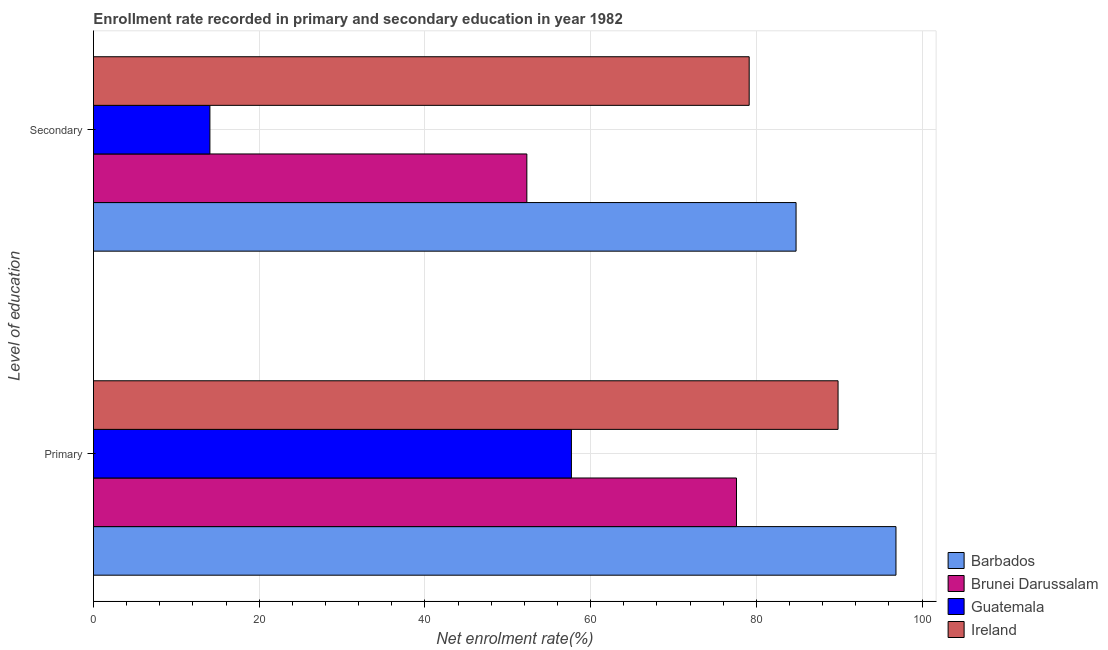How many groups of bars are there?
Provide a succinct answer. 2. Are the number of bars on each tick of the Y-axis equal?
Make the answer very short. Yes. How many bars are there on the 1st tick from the bottom?
Offer a terse response. 4. What is the label of the 1st group of bars from the top?
Keep it short and to the point. Secondary. What is the enrollment rate in secondary education in Guatemala?
Offer a terse response. 14.05. Across all countries, what is the maximum enrollment rate in secondary education?
Provide a succinct answer. 84.79. Across all countries, what is the minimum enrollment rate in secondary education?
Provide a short and direct response. 14.05. In which country was the enrollment rate in secondary education maximum?
Make the answer very short. Barbados. In which country was the enrollment rate in primary education minimum?
Your answer should be very brief. Guatemala. What is the total enrollment rate in primary education in the graph?
Your answer should be compact. 321.99. What is the difference between the enrollment rate in secondary education in Guatemala and that in Ireland?
Offer a very short reply. -65.08. What is the difference between the enrollment rate in primary education in Barbados and the enrollment rate in secondary education in Ireland?
Keep it short and to the point. 17.72. What is the average enrollment rate in primary education per country?
Your answer should be compact. 80.5. What is the difference between the enrollment rate in secondary education and enrollment rate in primary education in Guatemala?
Your answer should be very brief. -43.63. In how many countries, is the enrollment rate in primary education greater than 12 %?
Your response must be concise. 4. What is the ratio of the enrollment rate in secondary education in Brunei Darussalam to that in Guatemala?
Give a very brief answer. 3.72. Is the enrollment rate in secondary education in Ireland less than that in Guatemala?
Your response must be concise. No. In how many countries, is the enrollment rate in secondary education greater than the average enrollment rate in secondary education taken over all countries?
Offer a very short reply. 2. What does the 2nd bar from the top in Secondary represents?
Ensure brevity in your answer.  Guatemala. What does the 1st bar from the bottom in Secondary represents?
Offer a terse response. Barbados. Are all the bars in the graph horizontal?
Provide a succinct answer. Yes. What is the difference between two consecutive major ticks on the X-axis?
Provide a succinct answer. 20. Are the values on the major ticks of X-axis written in scientific E-notation?
Ensure brevity in your answer.  No. Does the graph contain any zero values?
Your answer should be very brief. No. How are the legend labels stacked?
Provide a short and direct response. Vertical. What is the title of the graph?
Provide a short and direct response. Enrollment rate recorded in primary and secondary education in year 1982. Does "Denmark" appear as one of the legend labels in the graph?
Your answer should be very brief. No. What is the label or title of the X-axis?
Your answer should be very brief. Net enrolment rate(%). What is the label or title of the Y-axis?
Ensure brevity in your answer.  Level of education. What is the Net enrolment rate(%) in Barbados in Primary?
Offer a very short reply. 96.85. What is the Net enrolment rate(%) in Brunei Darussalam in Primary?
Provide a short and direct response. 77.6. What is the Net enrolment rate(%) in Guatemala in Primary?
Your answer should be very brief. 57.68. What is the Net enrolment rate(%) of Ireland in Primary?
Give a very brief answer. 89.86. What is the Net enrolment rate(%) in Barbados in Secondary?
Give a very brief answer. 84.79. What is the Net enrolment rate(%) in Brunei Darussalam in Secondary?
Keep it short and to the point. 52.3. What is the Net enrolment rate(%) of Guatemala in Secondary?
Your response must be concise. 14.05. What is the Net enrolment rate(%) of Ireland in Secondary?
Give a very brief answer. 79.13. Across all Level of education, what is the maximum Net enrolment rate(%) in Barbados?
Give a very brief answer. 96.85. Across all Level of education, what is the maximum Net enrolment rate(%) in Brunei Darussalam?
Ensure brevity in your answer.  77.6. Across all Level of education, what is the maximum Net enrolment rate(%) in Guatemala?
Give a very brief answer. 57.68. Across all Level of education, what is the maximum Net enrolment rate(%) of Ireland?
Make the answer very short. 89.86. Across all Level of education, what is the minimum Net enrolment rate(%) of Barbados?
Provide a short and direct response. 84.79. Across all Level of education, what is the minimum Net enrolment rate(%) of Brunei Darussalam?
Make the answer very short. 52.3. Across all Level of education, what is the minimum Net enrolment rate(%) in Guatemala?
Offer a very short reply. 14.05. Across all Level of education, what is the minimum Net enrolment rate(%) of Ireland?
Your answer should be compact. 79.13. What is the total Net enrolment rate(%) of Barbados in the graph?
Your answer should be compact. 181.64. What is the total Net enrolment rate(%) in Brunei Darussalam in the graph?
Offer a terse response. 129.9. What is the total Net enrolment rate(%) of Guatemala in the graph?
Provide a succinct answer. 71.73. What is the total Net enrolment rate(%) in Ireland in the graph?
Keep it short and to the point. 168.99. What is the difference between the Net enrolment rate(%) of Barbados in Primary and that in Secondary?
Make the answer very short. 12.06. What is the difference between the Net enrolment rate(%) of Brunei Darussalam in Primary and that in Secondary?
Make the answer very short. 25.3. What is the difference between the Net enrolment rate(%) of Guatemala in Primary and that in Secondary?
Offer a terse response. 43.63. What is the difference between the Net enrolment rate(%) in Ireland in Primary and that in Secondary?
Provide a succinct answer. 10.73. What is the difference between the Net enrolment rate(%) of Barbados in Primary and the Net enrolment rate(%) of Brunei Darussalam in Secondary?
Offer a very short reply. 44.55. What is the difference between the Net enrolment rate(%) of Barbados in Primary and the Net enrolment rate(%) of Guatemala in Secondary?
Provide a succinct answer. 82.8. What is the difference between the Net enrolment rate(%) of Barbados in Primary and the Net enrolment rate(%) of Ireland in Secondary?
Your answer should be compact. 17.72. What is the difference between the Net enrolment rate(%) of Brunei Darussalam in Primary and the Net enrolment rate(%) of Guatemala in Secondary?
Provide a succinct answer. 63.55. What is the difference between the Net enrolment rate(%) of Brunei Darussalam in Primary and the Net enrolment rate(%) of Ireland in Secondary?
Your response must be concise. -1.53. What is the difference between the Net enrolment rate(%) in Guatemala in Primary and the Net enrolment rate(%) in Ireland in Secondary?
Make the answer very short. -21.45. What is the average Net enrolment rate(%) of Barbados per Level of education?
Offer a very short reply. 90.82. What is the average Net enrolment rate(%) in Brunei Darussalam per Level of education?
Ensure brevity in your answer.  64.95. What is the average Net enrolment rate(%) of Guatemala per Level of education?
Keep it short and to the point. 35.87. What is the average Net enrolment rate(%) of Ireland per Level of education?
Keep it short and to the point. 84.5. What is the difference between the Net enrolment rate(%) of Barbados and Net enrolment rate(%) of Brunei Darussalam in Primary?
Give a very brief answer. 19.25. What is the difference between the Net enrolment rate(%) of Barbados and Net enrolment rate(%) of Guatemala in Primary?
Provide a succinct answer. 39.17. What is the difference between the Net enrolment rate(%) of Barbados and Net enrolment rate(%) of Ireland in Primary?
Offer a terse response. 6.99. What is the difference between the Net enrolment rate(%) in Brunei Darussalam and Net enrolment rate(%) in Guatemala in Primary?
Keep it short and to the point. 19.92. What is the difference between the Net enrolment rate(%) in Brunei Darussalam and Net enrolment rate(%) in Ireland in Primary?
Give a very brief answer. -12.26. What is the difference between the Net enrolment rate(%) in Guatemala and Net enrolment rate(%) in Ireland in Primary?
Ensure brevity in your answer.  -32.18. What is the difference between the Net enrolment rate(%) in Barbados and Net enrolment rate(%) in Brunei Darussalam in Secondary?
Give a very brief answer. 32.49. What is the difference between the Net enrolment rate(%) in Barbados and Net enrolment rate(%) in Guatemala in Secondary?
Offer a terse response. 70.74. What is the difference between the Net enrolment rate(%) of Barbados and Net enrolment rate(%) of Ireland in Secondary?
Your answer should be very brief. 5.66. What is the difference between the Net enrolment rate(%) in Brunei Darussalam and Net enrolment rate(%) in Guatemala in Secondary?
Make the answer very short. 38.25. What is the difference between the Net enrolment rate(%) in Brunei Darussalam and Net enrolment rate(%) in Ireland in Secondary?
Provide a succinct answer. -26.83. What is the difference between the Net enrolment rate(%) in Guatemala and Net enrolment rate(%) in Ireland in Secondary?
Provide a short and direct response. -65.08. What is the ratio of the Net enrolment rate(%) in Barbados in Primary to that in Secondary?
Your answer should be very brief. 1.14. What is the ratio of the Net enrolment rate(%) of Brunei Darussalam in Primary to that in Secondary?
Ensure brevity in your answer.  1.48. What is the ratio of the Net enrolment rate(%) of Guatemala in Primary to that in Secondary?
Make the answer very short. 4.1. What is the ratio of the Net enrolment rate(%) of Ireland in Primary to that in Secondary?
Keep it short and to the point. 1.14. What is the difference between the highest and the second highest Net enrolment rate(%) in Barbados?
Your answer should be compact. 12.06. What is the difference between the highest and the second highest Net enrolment rate(%) in Brunei Darussalam?
Provide a short and direct response. 25.3. What is the difference between the highest and the second highest Net enrolment rate(%) in Guatemala?
Offer a terse response. 43.63. What is the difference between the highest and the second highest Net enrolment rate(%) of Ireland?
Give a very brief answer. 10.73. What is the difference between the highest and the lowest Net enrolment rate(%) of Barbados?
Your answer should be very brief. 12.06. What is the difference between the highest and the lowest Net enrolment rate(%) in Brunei Darussalam?
Give a very brief answer. 25.3. What is the difference between the highest and the lowest Net enrolment rate(%) of Guatemala?
Provide a succinct answer. 43.63. What is the difference between the highest and the lowest Net enrolment rate(%) of Ireland?
Provide a succinct answer. 10.73. 